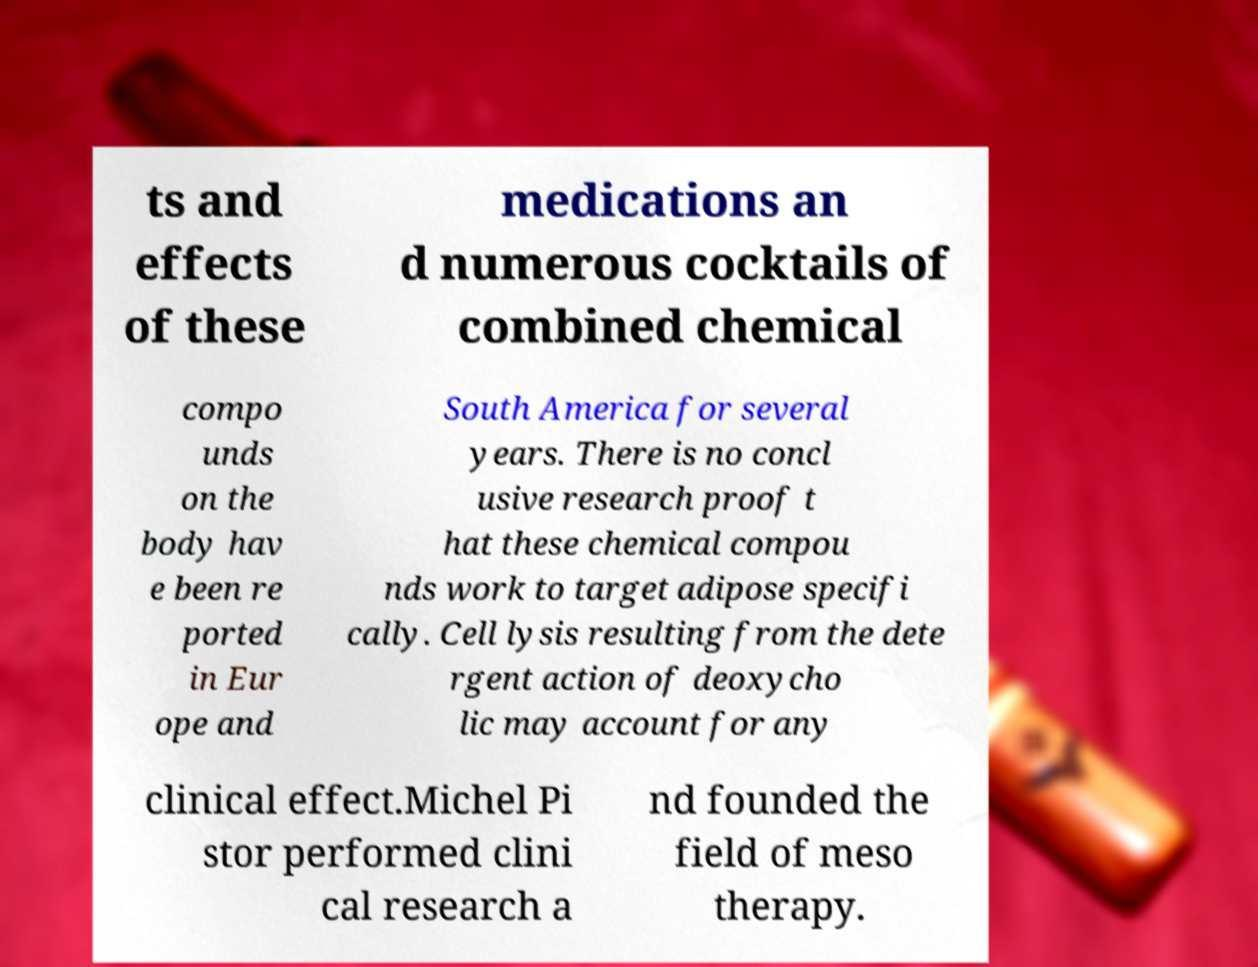What messages or text are displayed in this image? I need them in a readable, typed format. ts and effects of these medications an d numerous cocktails of combined chemical compo unds on the body hav e been re ported in Eur ope and South America for several years. There is no concl usive research proof t hat these chemical compou nds work to target adipose specifi cally. Cell lysis resulting from the dete rgent action of deoxycho lic may account for any clinical effect.Michel Pi stor performed clini cal research a nd founded the field of meso therapy. 